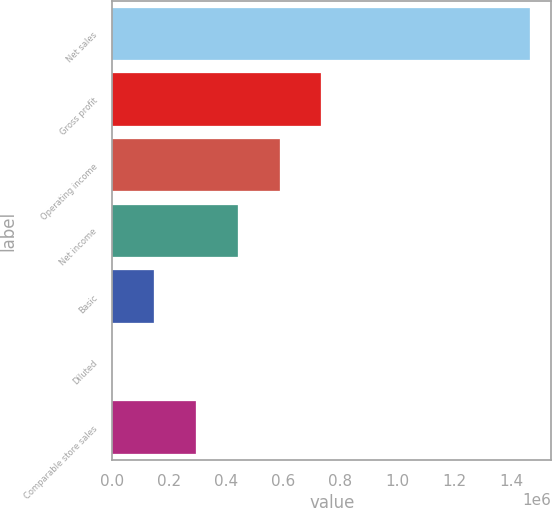Convert chart. <chart><loc_0><loc_0><loc_500><loc_500><bar_chart><fcel>Net sales<fcel>Gross profit<fcel>Operating income<fcel>Net income<fcel>Basic<fcel>Diluted<fcel>Comparable store sales<nl><fcel>1.4678e+06<fcel>733899<fcel>587119<fcel>440339<fcel>146780<fcel>0.5<fcel>293560<nl></chart> 